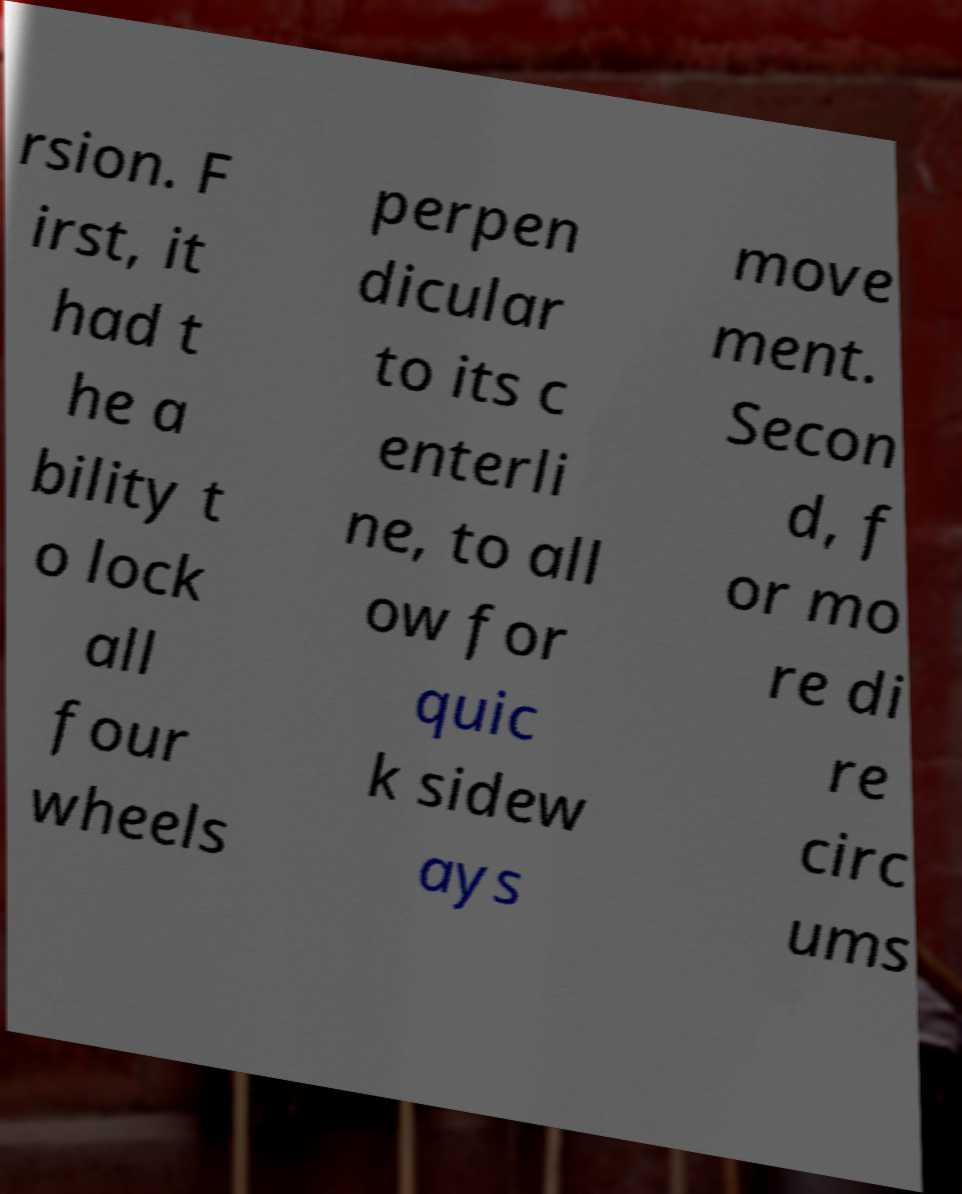Please identify and transcribe the text found in this image. rsion. F irst, it had t he a bility t o lock all four wheels perpen dicular to its c enterli ne, to all ow for quic k sidew ays move ment. Secon d, f or mo re di re circ ums 